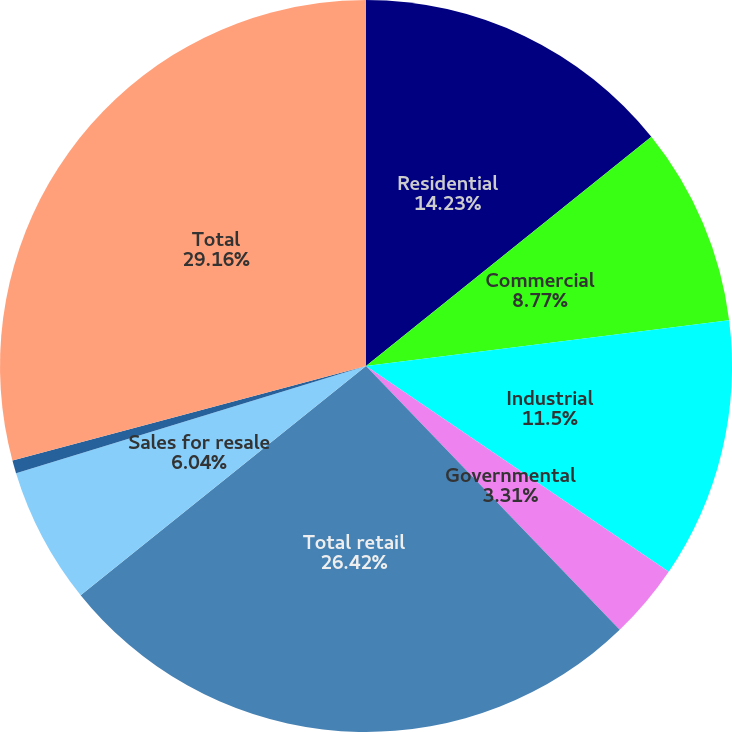<chart> <loc_0><loc_0><loc_500><loc_500><pie_chart><fcel>Residential<fcel>Commercial<fcel>Industrial<fcel>Governmental<fcel>Total retail<fcel>Sales for resale<fcel>Other (1)<fcel>Total<nl><fcel>14.23%<fcel>8.77%<fcel>11.5%<fcel>3.31%<fcel>26.42%<fcel>6.04%<fcel>0.57%<fcel>29.16%<nl></chart> 